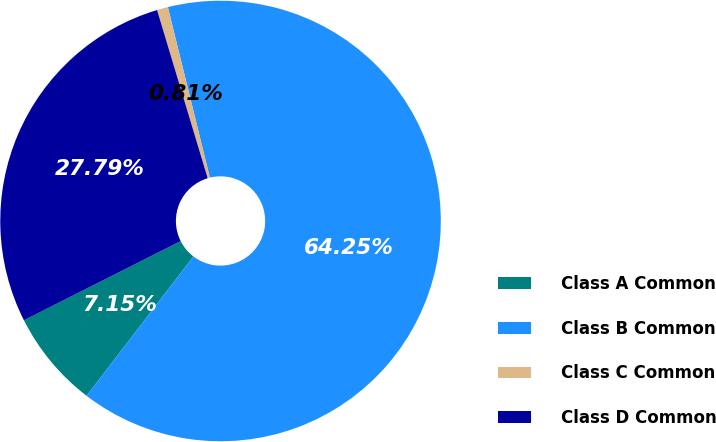Convert chart. <chart><loc_0><loc_0><loc_500><loc_500><pie_chart><fcel>Class A Common<fcel>Class B Common<fcel>Class C Common<fcel>Class D Common<nl><fcel>7.15%<fcel>64.25%<fcel>0.81%<fcel>27.79%<nl></chart> 